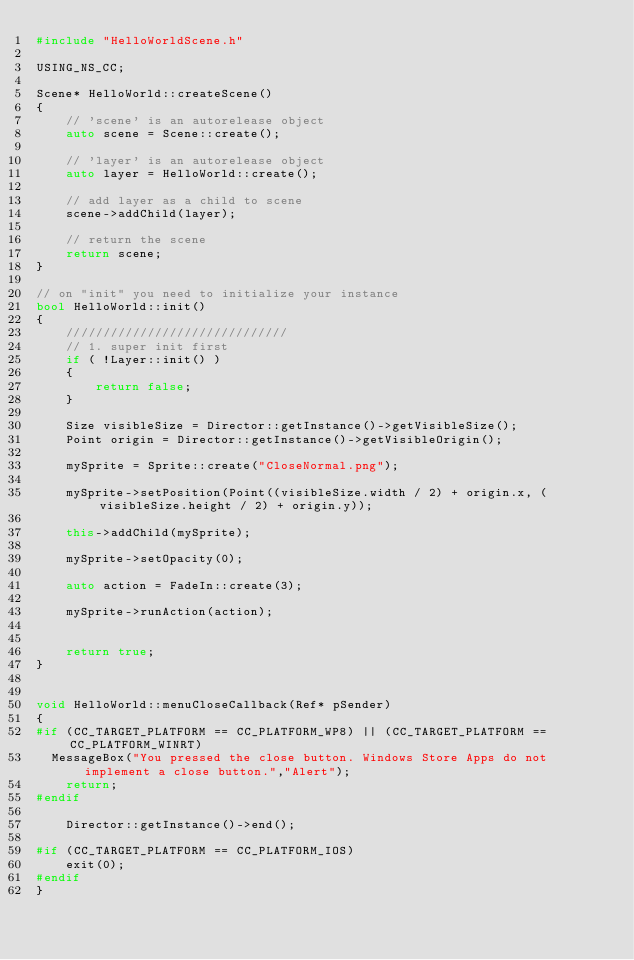<code> <loc_0><loc_0><loc_500><loc_500><_C++_>#include "HelloWorldScene.h"

USING_NS_CC;

Scene* HelloWorld::createScene()
{
    // 'scene' is an autorelease object
    auto scene = Scene::create();
    
    // 'layer' is an autorelease object
    auto layer = HelloWorld::create();

    // add layer as a child to scene
    scene->addChild(layer);

    // return the scene
    return scene;
}

// on "init" you need to initialize your instance
bool HelloWorld::init()
{
    //////////////////////////////
    // 1. super init first
    if ( !Layer::init() )
    {
        return false;
    }
    
    Size visibleSize = Director::getInstance()->getVisibleSize();
    Point origin = Director::getInstance()->getVisibleOrigin();

    mySprite = Sprite::create("CloseNormal.png");
    
    mySprite->setPosition(Point((visibleSize.width / 2) + origin.x, (visibleSize.height / 2) + origin.y));
    
    this->addChild(mySprite);
    
    mySprite->setOpacity(0);
    
    auto action = FadeIn::create(3);
    
    mySprite->runAction(action);
    
    
    return true;
}


void HelloWorld::menuCloseCallback(Ref* pSender)
{
#if (CC_TARGET_PLATFORM == CC_PLATFORM_WP8) || (CC_TARGET_PLATFORM == CC_PLATFORM_WINRT)
	MessageBox("You pressed the close button. Windows Store Apps do not implement a close button.","Alert");
    return;
#endif

    Director::getInstance()->end();

#if (CC_TARGET_PLATFORM == CC_PLATFORM_IOS)
    exit(0);
#endif
}
</code> 